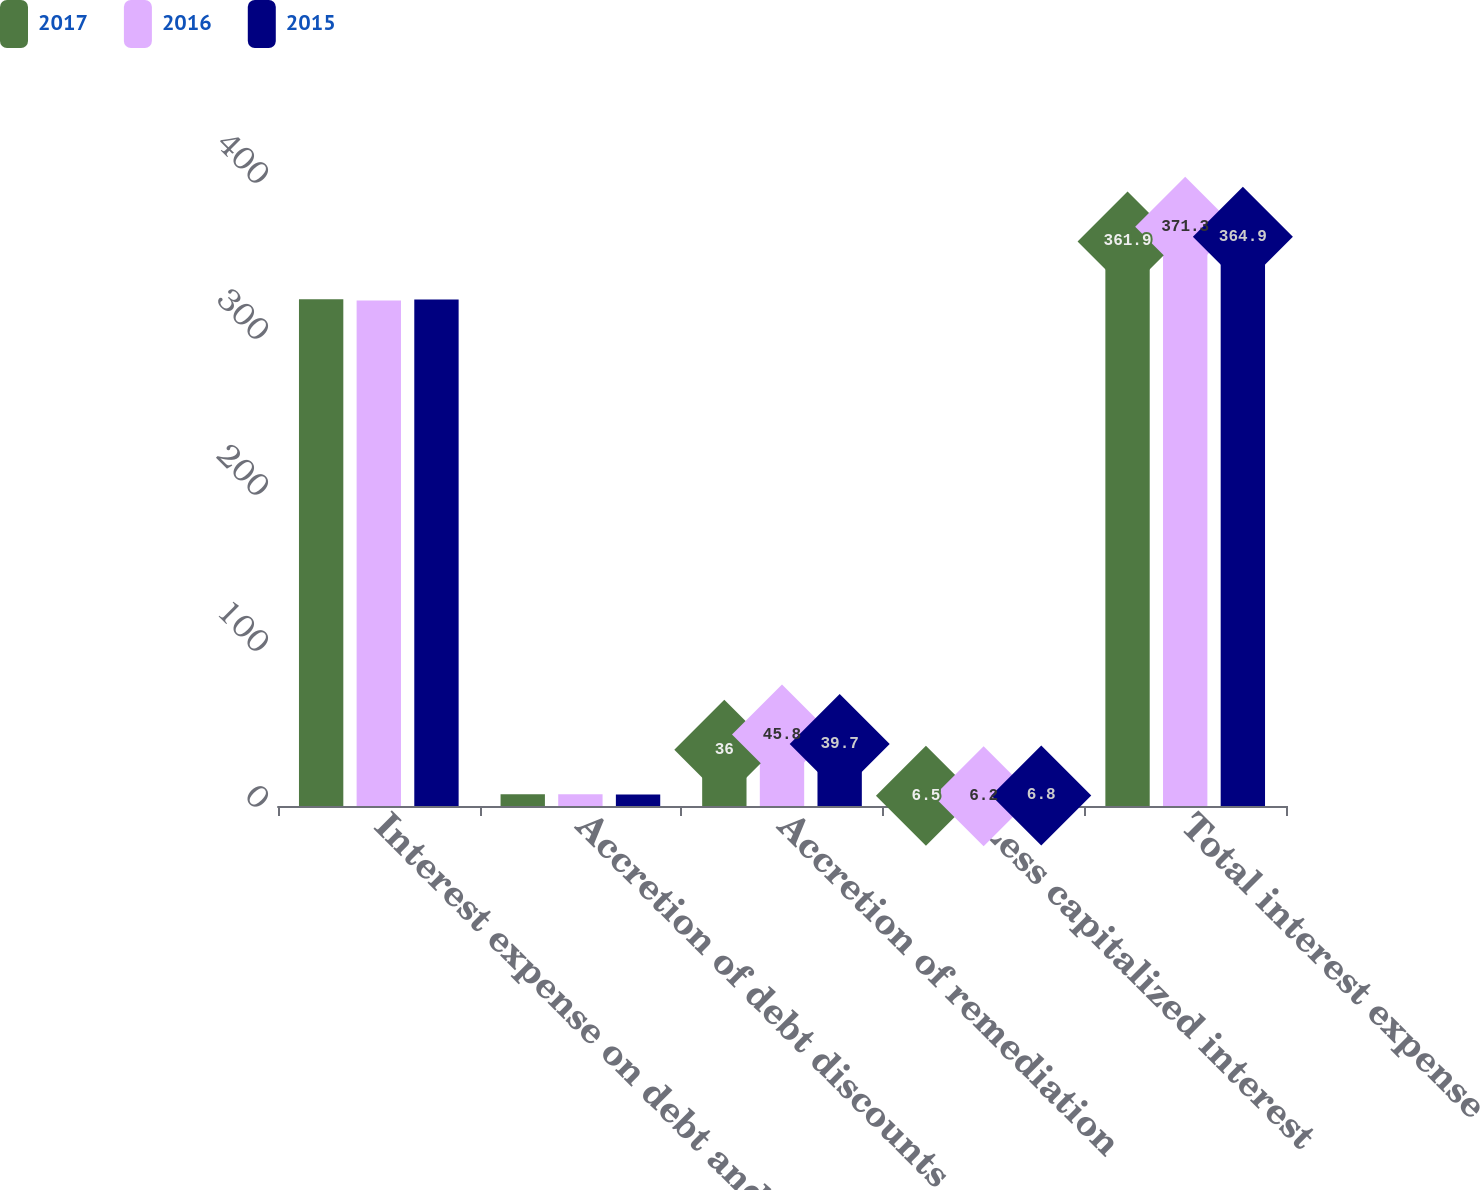Convert chart. <chart><loc_0><loc_0><loc_500><loc_500><stacked_bar_chart><ecel><fcel>Interest expense on debt and<fcel>Accretion of debt discounts<fcel>Accretion of remediation<fcel>Less capitalized interest<fcel>Total interest expense<nl><fcel>2017<fcel>324.8<fcel>7.6<fcel>36<fcel>6.5<fcel>361.9<nl><fcel>2016<fcel>324.1<fcel>7.6<fcel>45.8<fcel>6.2<fcel>371.3<nl><fcel>2015<fcel>324.6<fcel>7.4<fcel>39.7<fcel>6.8<fcel>364.9<nl></chart> 